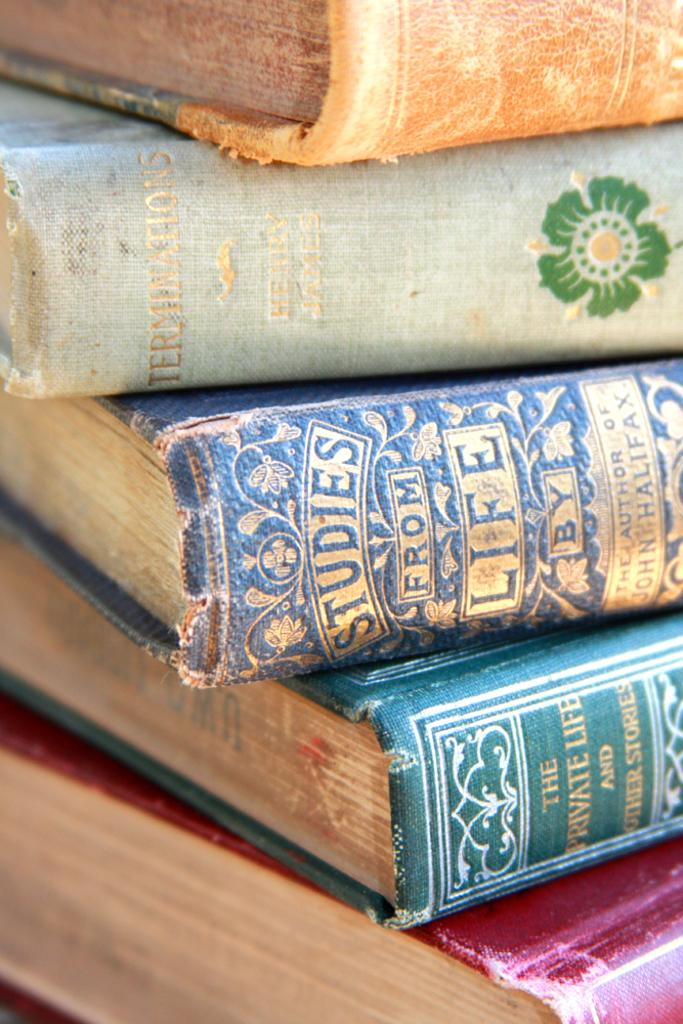Provide a one-sentence caption for the provided image. Three tattered hardcover books are titled Studies from Life. Private Life and Other Stories, and Terminations. 